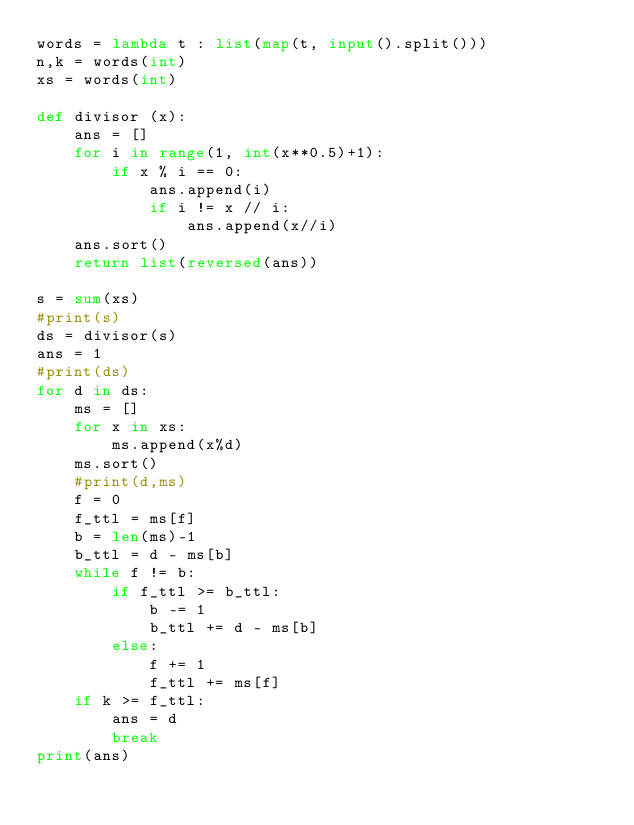<code> <loc_0><loc_0><loc_500><loc_500><_Python_>words = lambda t : list(map(t, input().split()))
n,k = words(int)
xs = words(int)

def divisor (x):
    ans = []
    for i in range(1, int(x**0.5)+1):
        if x % i == 0:
            ans.append(i)
            if i != x // i:
                ans.append(x//i)
    ans.sort()
    return list(reversed(ans))

s = sum(xs)
#print(s)
ds = divisor(s)
ans = 1
#print(ds)
for d in ds:
    ms = []
    for x in xs:
        ms.append(x%d)
    ms.sort()
    #print(d,ms)
    f = 0
    f_ttl = ms[f]
    b = len(ms)-1
    b_ttl = d - ms[b]
    while f != b:
        if f_ttl >= b_ttl:
            b -= 1
            b_ttl += d - ms[b]
        else:
            f += 1
            f_ttl += ms[f]
    if k >= f_ttl:
        ans = d
        break
print(ans)
</code> 